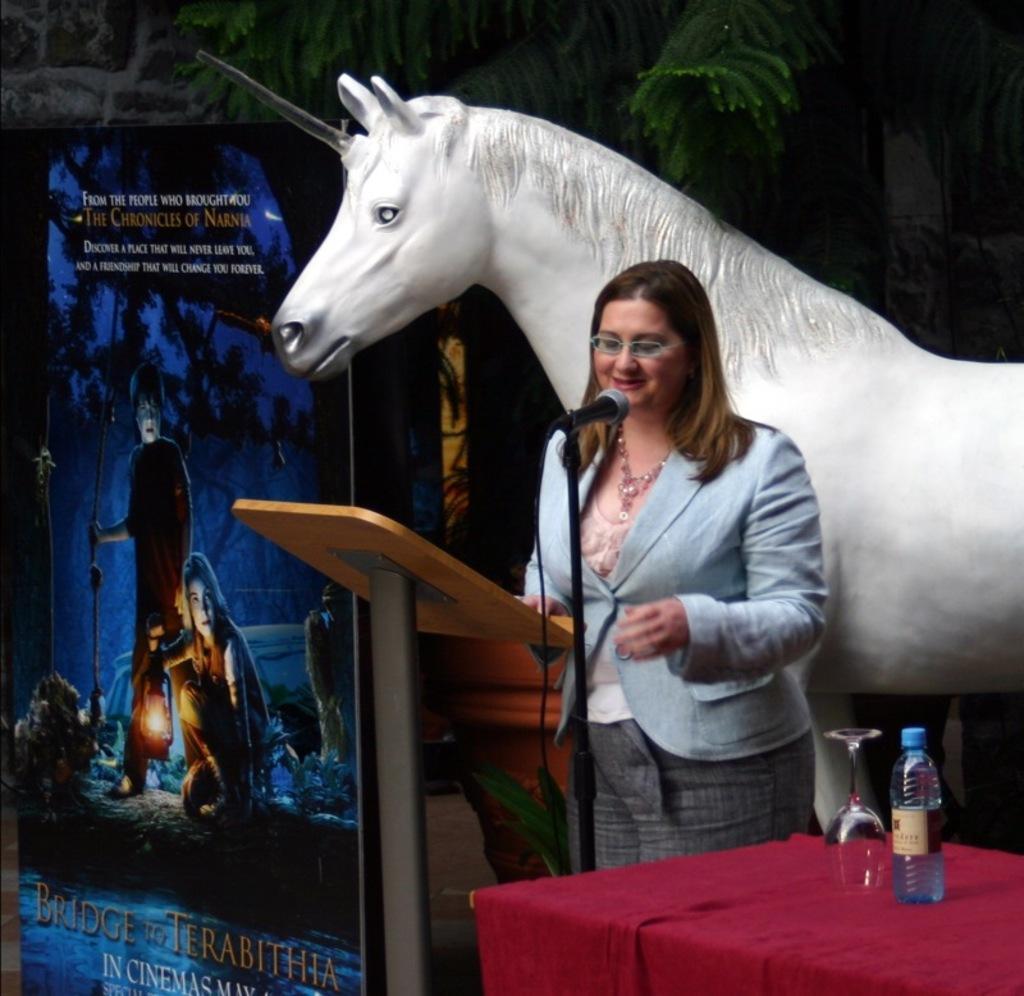Please provide a concise description of this image. A woman is standing at the podium and mic on a stand and on the right we can see glass and a water bottle on the table. In the background we can see a hoarding,plant,pot and a unicorn statue. 